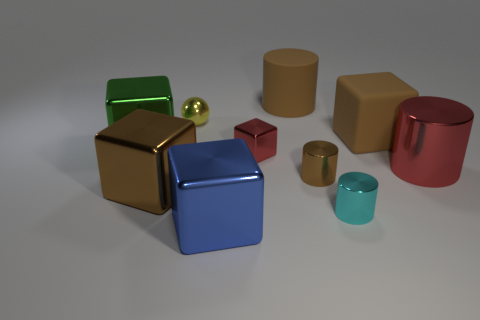Subtract all metal cylinders. How many cylinders are left? 1 Subtract all cyan cylinders. How many cylinders are left? 3 Subtract 2 blocks. How many blocks are left? 3 Subtract all tiny red objects. Subtract all small shiny balls. How many objects are left? 8 Add 9 red cubes. How many red cubes are left? 10 Add 2 tiny cylinders. How many tiny cylinders exist? 4 Subtract 0 gray cylinders. How many objects are left? 10 Subtract all balls. How many objects are left? 9 Subtract all gray cylinders. Subtract all purple spheres. How many cylinders are left? 4 Subtract all red cubes. How many cyan spheres are left? 0 